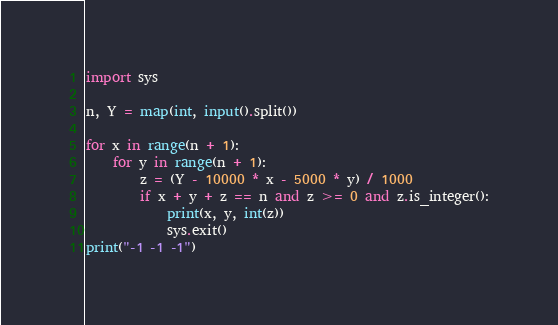<code> <loc_0><loc_0><loc_500><loc_500><_Python_>import sys

n, Y = map(int, input().split())

for x in range(n + 1):
    for y in range(n + 1):
        z = (Y - 10000 * x - 5000 * y) / 1000
        if x + y + z == n and z >= 0 and z.is_integer():
            print(x, y, int(z))
            sys.exit()
print("-1 -1 -1")

</code> 